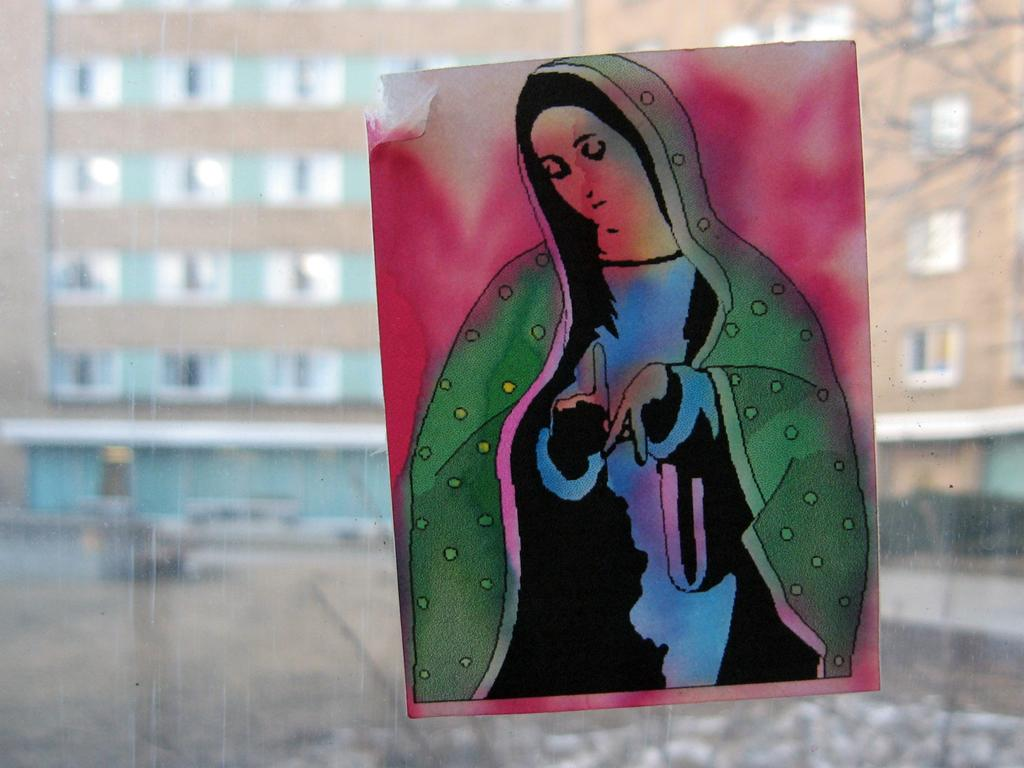What type of wall is present in the image? There is a glass wall in the image. What can be seen on the other side of the glass wall? A painting of a woman and a part of a building with windows are visible through the glass wall. Can you describe the painting in the image? The painting is of a woman. Where is the goose located in the image? There is no goose present in the image. What type of yard can be seen through the glass wall? There is no yard visible through the glass wall; only a part of a building with windows is visible. 